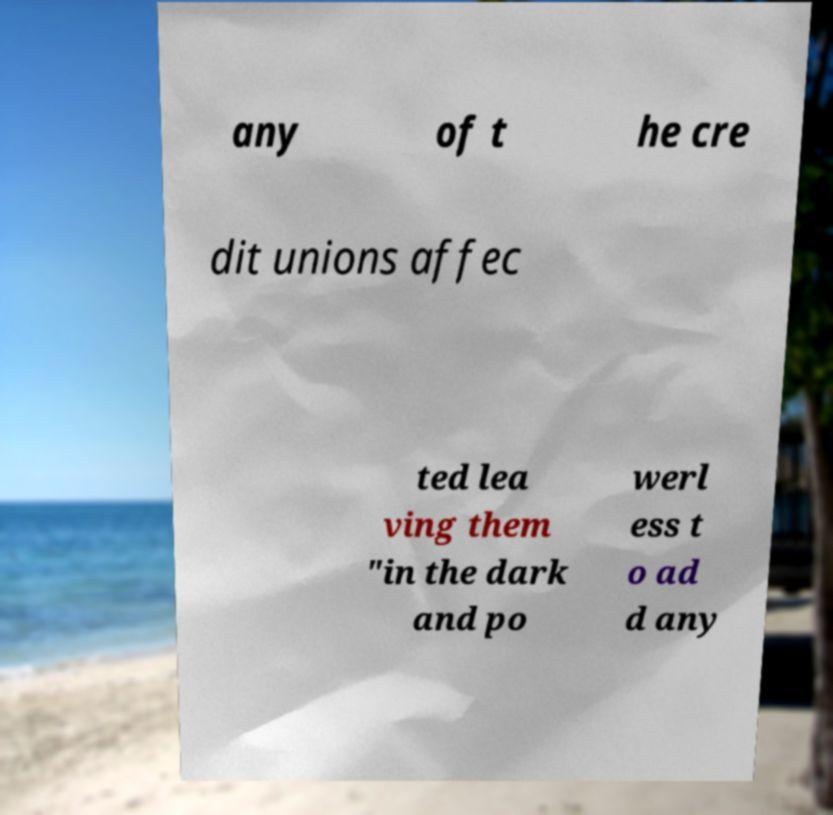I need the written content from this picture converted into text. Can you do that? any of t he cre dit unions affec ted lea ving them "in the dark and po werl ess t o ad d any 